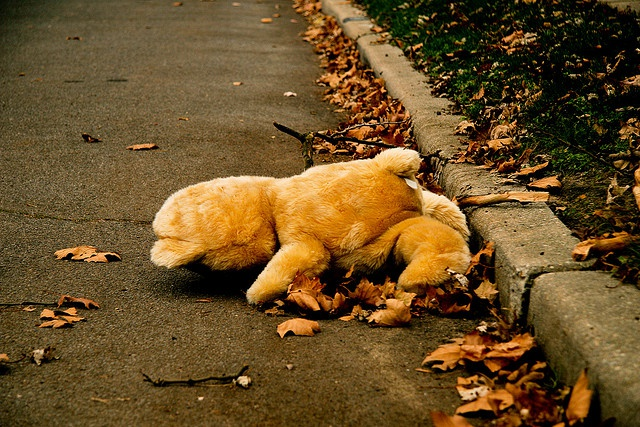Describe the objects in this image and their specific colors. I can see a teddy bear in black, orange, red, and tan tones in this image. 